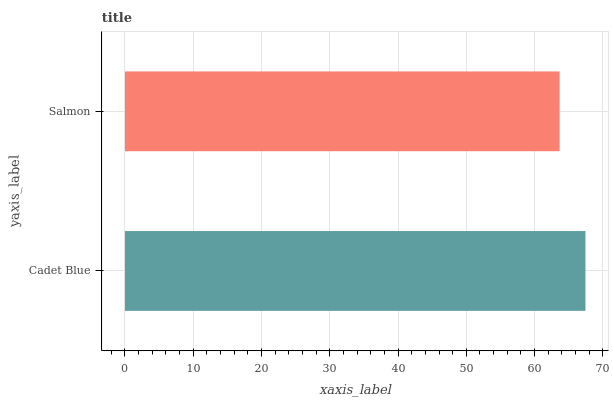Is Salmon the minimum?
Answer yes or no. Yes. Is Cadet Blue the maximum?
Answer yes or no. Yes. Is Salmon the maximum?
Answer yes or no. No. Is Cadet Blue greater than Salmon?
Answer yes or no. Yes. Is Salmon less than Cadet Blue?
Answer yes or no. Yes. Is Salmon greater than Cadet Blue?
Answer yes or no. No. Is Cadet Blue less than Salmon?
Answer yes or no. No. Is Cadet Blue the high median?
Answer yes or no. Yes. Is Salmon the low median?
Answer yes or no. Yes. Is Salmon the high median?
Answer yes or no. No. Is Cadet Blue the low median?
Answer yes or no. No. 